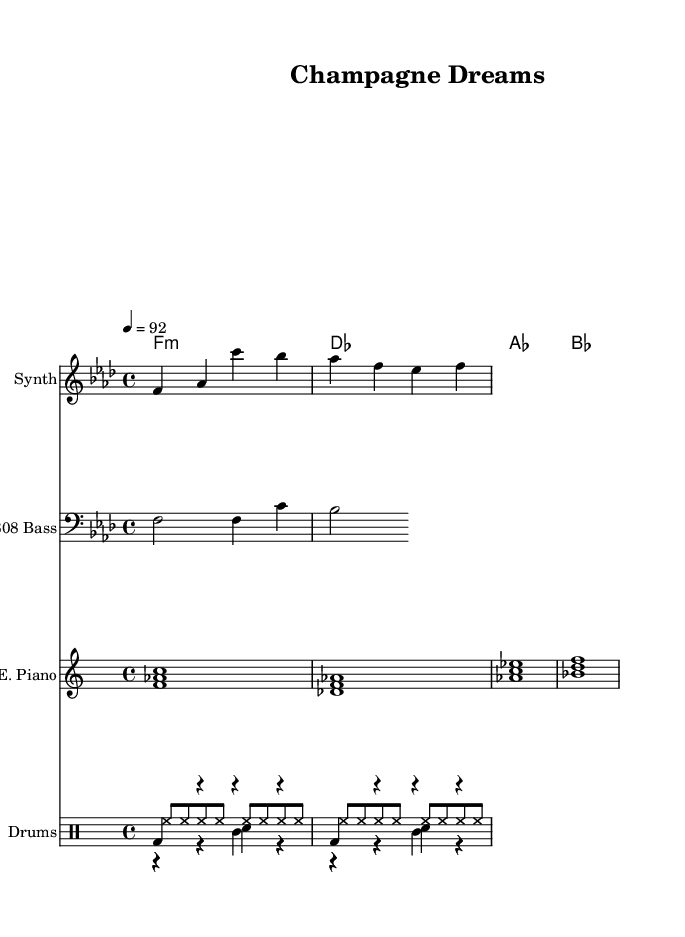What is the key signature of this music? The key signature is F minor, which consists of four flats (B♭, E♭, A♭, and D♭). This can be determined by looking at the opening of the sheet music, where it shows the key signature and indicates F minor.
Answer: F minor What is the time signature of this music? The time signature is 4/4, which means there are four beats in each measure and the quarter note gets one beat. This is indicated at the beginning of the score right after the key signature.
Answer: 4/4 What is the tempo marking for this piece? The tempo marking is 92, which indicates that the music should be played at 92 beats per minute. This can be identified from the tempo indication at the start of the score.
Answer: 92 What are the chord names used in this piece? The chord names listed are F minor, D♭ major, A♭ major, and B♭ major. These chords appear in the chord symbols section of the sheet music, specifically in the chord names line.
Answer: F minor, D♭, A♭, B♭ What type of bassline is utilized in the composition? The bassline is derived from an 808 sound, typically used in hip hop music for its deep and resonant qualities. This can be concluded from the instrument name indicated in the staff labeled "808 Bass."
Answer: 808 What rhythmic pattern is predominant in the drum section? The predominant rhythmic pattern in the drum section features a kick drum on the downbeats and a snare drum on the backbeats, typical of hip hop grooves. This can be analyzed by observing the notation for the kick and snare in their respective measures.
Answer: Kick on downbeats, snare on backbeats How does the melody relate to the overall theme of luxury? The melody incorporates smooth and flowing lines while aligning with high-end themes, often associated with luxury and affluence in hip hop. This can be seen in the melodious phrases and sophisticated chord structures that are synonymous with luxury lifestyle rap.
Answer: Smooth and flowing melodic lines 